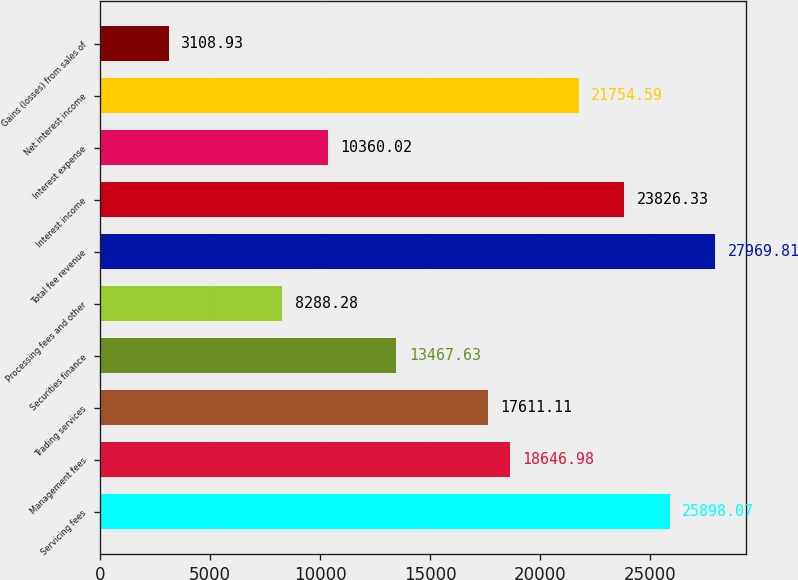<chart> <loc_0><loc_0><loc_500><loc_500><bar_chart><fcel>Servicing fees<fcel>Management fees<fcel>Trading services<fcel>Securities finance<fcel>Processing fees and other<fcel>Total fee revenue<fcel>Interest income<fcel>Interest expense<fcel>Net interest income<fcel>Gains (losses) from sales of<nl><fcel>25898.1<fcel>18647<fcel>17611.1<fcel>13467.6<fcel>8288.28<fcel>27969.8<fcel>23826.3<fcel>10360<fcel>21754.6<fcel>3108.93<nl></chart> 